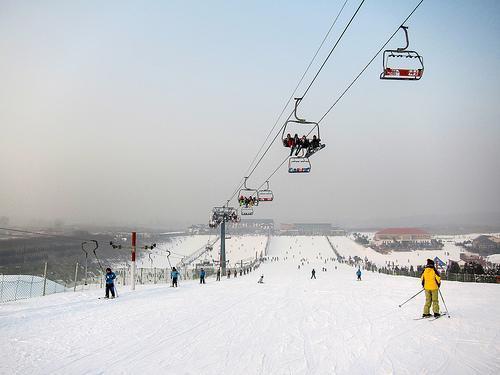How many people are visibly wearing yellow?
Give a very brief answer. 1. 